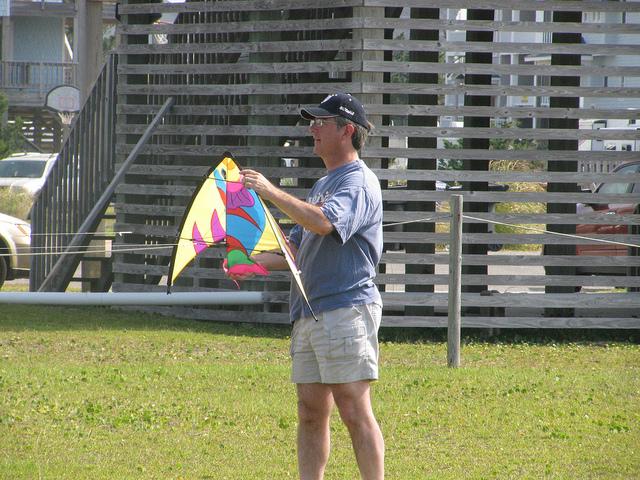What is the man holding in his right hand?
Concise answer only. Kite. Can you see a hoop?
Quick response, please. Yes. What is the man holding?
Concise answer only. Kite. Where is the person's right hand?
Quick response, please. Holding kite. What color is his hat?
Keep it brief. Black. What color is the kite?
Concise answer only. Multicolored. 